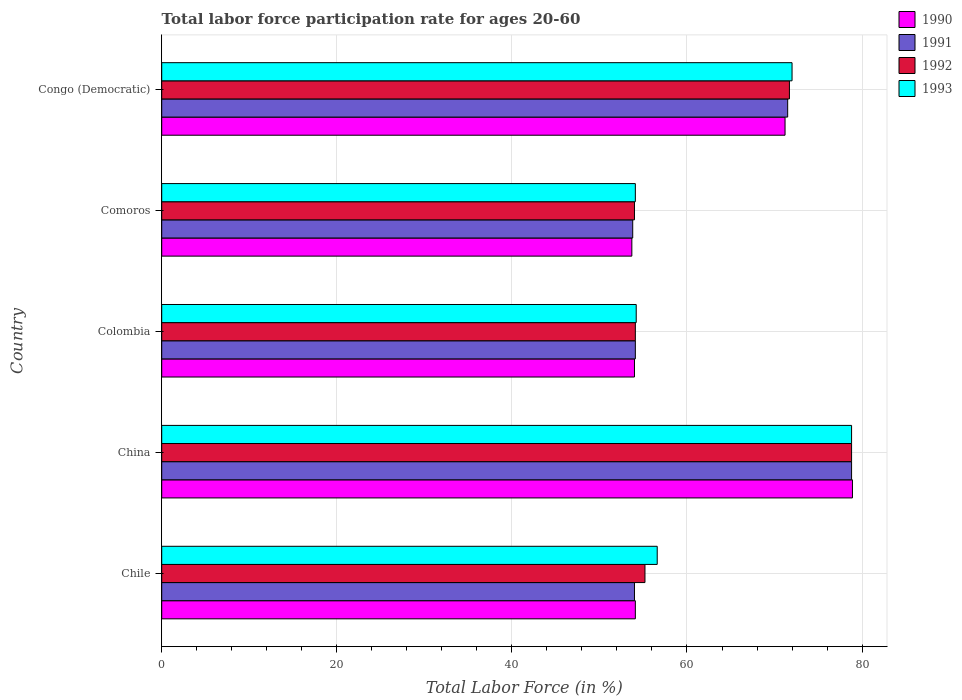How many different coloured bars are there?
Provide a succinct answer. 4. Are the number of bars per tick equal to the number of legend labels?
Offer a terse response. Yes. How many bars are there on the 1st tick from the top?
Make the answer very short. 4. How many bars are there on the 2nd tick from the bottom?
Provide a succinct answer. 4. In how many cases, is the number of bars for a given country not equal to the number of legend labels?
Provide a succinct answer. 0. What is the labor force participation rate in 1993 in Comoros?
Offer a terse response. 54.1. Across all countries, what is the maximum labor force participation rate in 1991?
Offer a very short reply. 78.8. Across all countries, what is the minimum labor force participation rate in 1993?
Your answer should be compact. 54.1. In which country was the labor force participation rate in 1991 minimum?
Your response must be concise. Comoros. What is the total labor force participation rate in 1993 in the graph?
Provide a succinct answer. 315.7. What is the difference between the labor force participation rate in 1990 in Chile and that in Comoros?
Your answer should be compact. 0.4. What is the average labor force participation rate in 1991 per country?
Your response must be concise. 62.44. What is the difference between the labor force participation rate in 1990 and labor force participation rate in 1991 in Comoros?
Your response must be concise. -0.1. What is the ratio of the labor force participation rate in 1991 in China to that in Comoros?
Keep it short and to the point. 1.46. What is the difference between the highest and the second highest labor force participation rate in 1991?
Provide a short and direct response. 7.3. What is the difference between the highest and the lowest labor force participation rate in 1991?
Offer a very short reply. 25. Is it the case that in every country, the sum of the labor force participation rate in 1993 and labor force participation rate in 1991 is greater than the sum of labor force participation rate in 1990 and labor force participation rate in 1992?
Offer a terse response. No. What does the 1st bar from the top in Comoros represents?
Your answer should be very brief. 1993. Are all the bars in the graph horizontal?
Make the answer very short. Yes. How many countries are there in the graph?
Your answer should be compact. 5. What is the difference between two consecutive major ticks on the X-axis?
Provide a short and direct response. 20. Does the graph contain any zero values?
Your answer should be compact. No. Does the graph contain grids?
Your answer should be very brief. Yes. Where does the legend appear in the graph?
Your response must be concise. Top right. How many legend labels are there?
Your response must be concise. 4. How are the legend labels stacked?
Keep it short and to the point. Vertical. What is the title of the graph?
Provide a succinct answer. Total labor force participation rate for ages 20-60. Does "1968" appear as one of the legend labels in the graph?
Provide a succinct answer. No. What is the label or title of the X-axis?
Provide a short and direct response. Total Labor Force (in %). What is the label or title of the Y-axis?
Offer a very short reply. Country. What is the Total Labor Force (in %) of 1990 in Chile?
Your answer should be very brief. 54.1. What is the Total Labor Force (in %) in 1991 in Chile?
Offer a terse response. 54. What is the Total Labor Force (in %) of 1992 in Chile?
Make the answer very short. 55.2. What is the Total Labor Force (in %) of 1993 in Chile?
Give a very brief answer. 56.6. What is the Total Labor Force (in %) in 1990 in China?
Give a very brief answer. 78.9. What is the Total Labor Force (in %) of 1991 in China?
Your answer should be very brief. 78.8. What is the Total Labor Force (in %) of 1992 in China?
Keep it short and to the point. 78.8. What is the Total Labor Force (in %) in 1993 in China?
Offer a very short reply. 78.8. What is the Total Labor Force (in %) of 1991 in Colombia?
Ensure brevity in your answer.  54.1. What is the Total Labor Force (in %) in 1992 in Colombia?
Provide a succinct answer. 54.1. What is the Total Labor Force (in %) in 1993 in Colombia?
Your answer should be very brief. 54.2. What is the Total Labor Force (in %) of 1990 in Comoros?
Your answer should be very brief. 53.7. What is the Total Labor Force (in %) of 1991 in Comoros?
Make the answer very short. 53.8. What is the Total Labor Force (in %) in 1993 in Comoros?
Ensure brevity in your answer.  54.1. What is the Total Labor Force (in %) in 1990 in Congo (Democratic)?
Provide a succinct answer. 71.2. What is the Total Labor Force (in %) of 1991 in Congo (Democratic)?
Ensure brevity in your answer.  71.5. What is the Total Labor Force (in %) of 1992 in Congo (Democratic)?
Offer a very short reply. 71.7. What is the Total Labor Force (in %) of 1993 in Congo (Democratic)?
Your response must be concise. 72. Across all countries, what is the maximum Total Labor Force (in %) of 1990?
Offer a very short reply. 78.9. Across all countries, what is the maximum Total Labor Force (in %) of 1991?
Your answer should be very brief. 78.8. Across all countries, what is the maximum Total Labor Force (in %) of 1992?
Ensure brevity in your answer.  78.8. Across all countries, what is the maximum Total Labor Force (in %) of 1993?
Ensure brevity in your answer.  78.8. Across all countries, what is the minimum Total Labor Force (in %) of 1990?
Ensure brevity in your answer.  53.7. Across all countries, what is the minimum Total Labor Force (in %) in 1991?
Offer a very short reply. 53.8. Across all countries, what is the minimum Total Labor Force (in %) in 1992?
Your answer should be very brief. 54. Across all countries, what is the minimum Total Labor Force (in %) of 1993?
Your response must be concise. 54.1. What is the total Total Labor Force (in %) of 1990 in the graph?
Provide a short and direct response. 311.9. What is the total Total Labor Force (in %) of 1991 in the graph?
Your response must be concise. 312.2. What is the total Total Labor Force (in %) of 1992 in the graph?
Give a very brief answer. 313.8. What is the total Total Labor Force (in %) of 1993 in the graph?
Keep it short and to the point. 315.7. What is the difference between the Total Labor Force (in %) in 1990 in Chile and that in China?
Your answer should be very brief. -24.8. What is the difference between the Total Labor Force (in %) in 1991 in Chile and that in China?
Make the answer very short. -24.8. What is the difference between the Total Labor Force (in %) in 1992 in Chile and that in China?
Keep it short and to the point. -23.6. What is the difference between the Total Labor Force (in %) in 1993 in Chile and that in China?
Offer a terse response. -22.2. What is the difference between the Total Labor Force (in %) in 1992 in Chile and that in Colombia?
Offer a terse response. 1.1. What is the difference between the Total Labor Force (in %) of 1993 in Chile and that in Colombia?
Keep it short and to the point. 2.4. What is the difference between the Total Labor Force (in %) of 1991 in Chile and that in Comoros?
Give a very brief answer. 0.2. What is the difference between the Total Labor Force (in %) of 1992 in Chile and that in Comoros?
Ensure brevity in your answer.  1.2. What is the difference between the Total Labor Force (in %) of 1993 in Chile and that in Comoros?
Your answer should be very brief. 2.5. What is the difference between the Total Labor Force (in %) of 1990 in Chile and that in Congo (Democratic)?
Your response must be concise. -17.1. What is the difference between the Total Labor Force (in %) of 1991 in Chile and that in Congo (Democratic)?
Make the answer very short. -17.5. What is the difference between the Total Labor Force (in %) of 1992 in Chile and that in Congo (Democratic)?
Give a very brief answer. -16.5. What is the difference between the Total Labor Force (in %) in 1993 in Chile and that in Congo (Democratic)?
Offer a terse response. -15.4. What is the difference between the Total Labor Force (in %) in 1990 in China and that in Colombia?
Your answer should be very brief. 24.9. What is the difference between the Total Labor Force (in %) in 1991 in China and that in Colombia?
Your response must be concise. 24.7. What is the difference between the Total Labor Force (in %) in 1992 in China and that in Colombia?
Your answer should be compact. 24.7. What is the difference between the Total Labor Force (in %) of 1993 in China and that in Colombia?
Keep it short and to the point. 24.6. What is the difference between the Total Labor Force (in %) of 1990 in China and that in Comoros?
Your answer should be very brief. 25.2. What is the difference between the Total Labor Force (in %) of 1992 in China and that in Comoros?
Your answer should be very brief. 24.8. What is the difference between the Total Labor Force (in %) in 1993 in China and that in Comoros?
Your response must be concise. 24.7. What is the difference between the Total Labor Force (in %) in 1991 in China and that in Congo (Democratic)?
Your response must be concise. 7.3. What is the difference between the Total Labor Force (in %) of 1992 in China and that in Congo (Democratic)?
Offer a very short reply. 7.1. What is the difference between the Total Labor Force (in %) in 1993 in China and that in Congo (Democratic)?
Provide a succinct answer. 6.8. What is the difference between the Total Labor Force (in %) in 1990 in Colombia and that in Comoros?
Keep it short and to the point. 0.3. What is the difference between the Total Labor Force (in %) of 1991 in Colombia and that in Comoros?
Your answer should be very brief. 0.3. What is the difference between the Total Labor Force (in %) of 1993 in Colombia and that in Comoros?
Provide a succinct answer. 0.1. What is the difference between the Total Labor Force (in %) of 1990 in Colombia and that in Congo (Democratic)?
Your response must be concise. -17.2. What is the difference between the Total Labor Force (in %) of 1991 in Colombia and that in Congo (Democratic)?
Offer a terse response. -17.4. What is the difference between the Total Labor Force (in %) of 1992 in Colombia and that in Congo (Democratic)?
Keep it short and to the point. -17.6. What is the difference between the Total Labor Force (in %) of 1993 in Colombia and that in Congo (Democratic)?
Your answer should be compact. -17.8. What is the difference between the Total Labor Force (in %) in 1990 in Comoros and that in Congo (Democratic)?
Provide a succinct answer. -17.5. What is the difference between the Total Labor Force (in %) in 1991 in Comoros and that in Congo (Democratic)?
Offer a terse response. -17.7. What is the difference between the Total Labor Force (in %) of 1992 in Comoros and that in Congo (Democratic)?
Keep it short and to the point. -17.7. What is the difference between the Total Labor Force (in %) in 1993 in Comoros and that in Congo (Democratic)?
Offer a terse response. -17.9. What is the difference between the Total Labor Force (in %) of 1990 in Chile and the Total Labor Force (in %) of 1991 in China?
Offer a very short reply. -24.7. What is the difference between the Total Labor Force (in %) in 1990 in Chile and the Total Labor Force (in %) in 1992 in China?
Offer a very short reply. -24.7. What is the difference between the Total Labor Force (in %) in 1990 in Chile and the Total Labor Force (in %) in 1993 in China?
Your response must be concise. -24.7. What is the difference between the Total Labor Force (in %) in 1991 in Chile and the Total Labor Force (in %) in 1992 in China?
Your answer should be very brief. -24.8. What is the difference between the Total Labor Force (in %) of 1991 in Chile and the Total Labor Force (in %) of 1993 in China?
Make the answer very short. -24.8. What is the difference between the Total Labor Force (in %) in 1992 in Chile and the Total Labor Force (in %) in 1993 in China?
Offer a very short reply. -23.6. What is the difference between the Total Labor Force (in %) of 1990 in Chile and the Total Labor Force (in %) of 1991 in Colombia?
Your answer should be compact. 0. What is the difference between the Total Labor Force (in %) of 1990 in Chile and the Total Labor Force (in %) of 1992 in Comoros?
Provide a short and direct response. 0.1. What is the difference between the Total Labor Force (in %) in 1990 in Chile and the Total Labor Force (in %) in 1993 in Comoros?
Your answer should be very brief. 0. What is the difference between the Total Labor Force (in %) in 1991 in Chile and the Total Labor Force (in %) in 1992 in Comoros?
Keep it short and to the point. 0. What is the difference between the Total Labor Force (in %) of 1992 in Chile and the Total Labor Force (in %) of 1993 in Comoros?
Offer a terse response. 1.1. What is the difference between the Total Labor Force (in %) in 1990 in Chile and the Total Labor Force (in %) in 1991 in Congo (Democratic)?
Ensure brevity in your answer.  -17.4. What is the difference between the Total Labor Force (in %) of 1990 in Chile and the Total Labor Force (in %) of 1992 in Congo (Democratic)?
Offer a terse response. -17.6. What is the difference between the Total Labor Force (in %) in 1990 in Chile and the Total Labor Force (in %) in 1993 in Congo (Democratic)?
Give a very brief answer. -17.9. What is the difference between the Total Labor Force (in %) in 1991 in Chile and the Total Labor Force (in %) in 1992 in Congo (Democratic)?
Provide a short and direct response. -17.7. What is the difference between the Total Labor Force (in %) in 1991 in Chile and the Total Labor Force (in %) in 1993 in Congo (Democratic)?
Your answer should be compact. -18. What is the difference between the Total Labor Force (in %) in 1992 in Chile and the Total Labor Force (in %) in 1993 in Congo (Democratic)?
Give a very brief answer. -16.8. What is the difference between the Total Labor Force (in %) of 1990 in China and the Total Labor Force (in %) of 1991 in Colombia?
Give a very brief answer. 24.8. What is the difference between the Total Labor Force (in %) in 1990 in China and the Total Labor Force (in %) in 1992 in Colombia?
Keep it short and to the point. 24.8. What is the difference between the Total Labor Force (in %) in 1990 in China and the Total Labor Force (in %) in 1993 in Colombia?
Your answer should be compact. 24.7. What is the difference between the Total Labor Force (in %) in 1991 in China and the Total Labor Force (in %) in 1992 in Colombia?
Provide a short and direct response. 24.7. What is the difference between the Total Labor Force (in %) in 1991 in China and the Total Labor Force (in %) in 1993 in Colombia?
Your answer should be compact. 24.6. What is the difference between the Total Labor Force (in %) in 1992 in China and the Total Labor Force (in %) in 1993 in Colombia?
Give a very brief answer. 24.6. What is the difference between the Total Labor Force (in %) in 1990 in China and the Total Labor Force (in %) in 1991 in Comoros?
Provide a succinct answer. 25.1. What is the difference between the Total Labor Force (in %) of 1990 in China and the Total Labor Force (in %) of 1992 in Comoros?
Keep it short and to the point. 24.9. What is the difference between the Total Labor Force (in %) in 1990 in China and the Total Labor Force (in %) in 1993 in Comoros?
Keep it short and to the point. 24.8. What is the difference between the Total Labor Force (in %) of 1991 in China and the Total Labor Force (in %) of 1992 in Comoros?
Make the answer very short. 24.8. What is the difference between the Total Labor Force (in %) in 1991 in China and the Total Labor Force (in %) in 1993 in Comoros?
Your answer should be compact. 24.7. What is the difference between the Total Labor Force (in %) of 1992 in China and the Total Labor Force (in %) of 1993 in Comoros?
Give a very brief answer. 24.7. What is the difference between the Total Labor Force (in %) in 1990 in China and the Total Labor Force (in %) in 1991 in Congo (Democratic)?
Give a very brief answer. 7.4. What is the difference between the Total Labor Force (in %) of 1991 in China and the Total Labor Force (in %) of 1992 in Congo (Democratic)?
Keep it short and to the point. 7.1. What is the difference between the Total Labor Force (in %) in 1990 in Colombia and the Total Labor Force (in %) in 1991 in Comoros?
Give a very brief answer. 0.2. What is the difference between the Total Labor Force (in %) in 1990 in Colombia and the Total Labor Force (in %) in 1992 in Comoros?
Make the answer very short. 0. What is the difference between the Total Labor Force (in %) of 1990 in Colombia and the Total Labor Force (in %) of 1993 in Comoros?
Provide a succinct answer. -0.1. What is the difference between the Total Labor Force (in %) in 1992 in Colombia and the Total Labor Force (in %) in 1993 in Comoros?
Provide a short and direct response. 0. What is the difference between the Total Labor Force (in %) in 1990 in Colombia and the Total Labor Force (in %) in 1991 in Congo (Democratic)?
Offer a terse response. -17.5. What is the difference between the Total Labor Force (in %) in 1990 in Colombia and the Total Labor Force (in %) in 1992 in Congo (Democratic)?
Give a very brief answer. -17.7. What is the difference between the Total Labor Force (in %) in 1990 in Colombia and the Total Labor Force (in %) in 1993 in Congo (Democratic)?
Provide a short and direct response. -18. What is the difference between the Total Labor Force (in %) of 1991 in Colombia and the Total Labor Force (in %) of 1992 in Congo (Democratic)?
Make the answer very short. -17.6. What is the difference between the Total Labor Force (in %) in 1991 in Colombia and the Total Labor Force (in %) in 1993 in Congo (Democratic)?
Keep it short and to the point. -17.9. What is the difference between the Total Labor Force (in %) in 1992 in Colombia and the Total Labor Force (in %) in 1993 in Congo (Democratic)?
Make the answer very short. -17.9. What is the difference between the Total Labor Force (in %) in 1990 in Comoros and the Total Labor Force (in %) in 1991 in Congo (Democratic)?
Provide a succinct answer. -17.8. What is the difference between the Total Labor Force (in %) of 1990 in Comoros and the Total Labor Force (in %) of 1993 in Congo (Democratic)?
Offer a terse response. -18.3. What is the difference between the Total Labor Force (in %) of 1991 in Comoros and the Total Labor Force (in %) of 1992 in Congo (Democratic)?
Offer a very short reply. -17.9. What is the difference between the Total Labor Force (in %) in 1991 in Comoros and the Total Labor Force (in %) in 1993 in Congo (Democratic)?
Your answer should be compact. -18.2. What is the average Total Labor Force (in %) in 1990 per country?
Provide a short and direct response. 62.38. What is the average Total Labor Force (in %) of 1991 per country?
Make the answer very short. 62.44. What is the average Total Labor Force (in %) in 1992 per country?
Offer a terse response. 62.76. What is the average Total Labor Force (in %) of 1993 per country?
Ensure brevity in your answer.  63.14. What is the difference between the Total Labor Force (in %) in 1990 and Total Labor Force (in %) in 1991 in Chile?
Your answer should be very brief. 0.1. What is the difference between the Total Labor Force (in %) of 1990 and Total Labor Force (in %) of 1991 in China?
Provide a short and direct response. 0.1. What is the difference between the Total Labor Force (in %) of 1990 and Total Labor Force (in %) of 1992 in China?
Your answer should be very brief. 0.1. What is the difference between the Total Labor Force (in %) of 1991 and Total Labor Force (in %) of 1993 in China?
Your answer should be very brief. 0. What is the difference between the Total Labor Force (in %) in 1990 and Total Labor Force (in %) in 1991 in Colombia?
Your response must be concise. -0.1. What is the difference between the Total Labor Force (in %) of 1990 and Total Labor Force (in %) of 1992 in Colombia?
Your answer should be very brief. -0.1. What is the difference between the Total Labor Force (in %) in 1991 and Total Labor Force (in %) in 1993 in Colombia?
Offer a terse response. -0.1. What is the difference between the Total Labor Force (in %) of 1990 and Total Labor Force (in %) of 1992 in Comoros?
Your answer should be compact. -0.3. What is the difference between the Total Labor Force (in %) in 1990 and Total Labor Force (in %) in 1993 in Comoros?
Your answer should be very brief. -0.4. What is the difference between the Total Labor Force (in %) in 1991 and Total Labor Force (in %) in 1992 in Comoros?
Keep it short and to the point. -0.2. What is the difference between the Total Labor Force (in %) in 1991 and Total Labor Force (in %) in 1993 in Comoros?
Your response must be concise. -0.3. What is the difference between the Total Labor Force (in %) of 1992 and Total Labor Force (in %) of 1993 in Comoros?
Provide a short and direct response. -0.1. What is the difference between the Total Labor Force (in %) of 1990 and Total Labor Force (in %) of 1992 in Congo (Democratic)?
Give a very brief answer. -0.5. What is the difference between the Total Labor Force (in %) in 1992 and Total Labor Force (in %) in 1993 in Congo (Democratic)?
Provide a short and direct response. -0.3. What is the ratio of the Total Labor Force (in %) in 1990 in Chile to that in China?
Offer a very short reply. 0.69. What is the ratio of the Total Labor Force (in %) in 1991 in Chile to that in China?
Make the answer very short. 0.69. What is the ratio of the Total Labor Force (in %) in 1992 in Chile to that in China?
Keep it short and to the point. 0.7. What is the ratio of the Total Labor Force (in %) in 1993 in Chile to that in China?
Ensure brevity in your answer.  0.72. What is the ratio of the Total Labor Force (in %) in 1991 in Chile to that in Colombia?
Provide a succinct answer. 1. What is the ratio of the Total Labor Force (in %) of 1992 in Chile to that in Colombia?
Make the answer very short. 1.02. What is the ratio of the Total Labor Force (in %) of 1993 in Chile to that in Colombia?
Offer a terse response. 1.04. What is the ratio of the Total Labor Force (in %) in 1990 in Chile to that in Comoros?
Your answer should be compact. 1.01. What is the ratio of the Total Labor Force (in %) in 1992 in Chile to that in Comoros?
Give a very brief answer. 1.02. What is the ratio of the Total Labor Force (in %) of 1993 in Chile to that in Comoros?
Offer a terse response. 1.05. What is the ratio of the Total Labor Force (in %) in 1990 in Chile to that in Congo (Democratic)?
Provide a succinct answer. 0.76. What is the ratio of the Total Labor Force (in %) in 1991 in Chile to that in Congo (Democratic)?
Make the answer very short. 0.76. What is the ratio of the Total Labor Force (in %) in 1992 in Chile to that in Congo (Democratic)?
Your answer should be compact. 0.77. What is the ratio of the Total Labor Force (in %) in 1993 in Chile to that in Congo (Democratic)?
Give a very brief answer. 0.79. What is the ratio of the Total Labor Force (in %) of 1990 in China to that in Colombia?
Offer a very short reply. 1.46. What is the ratio of the Total Labor Force (in %) of 1991 in China to that in Colombia?
Make the answer very short. 1.46. What is the ratio of the Total Labor Force (in %) in 1992 in China to that in Colombia?
Ensure brevity in your answer.  1.46. What is the ratio of the Total Labor Force (in %) of 1993 in China to that in Colombia?
Your response must be concise. 1.45. What is the ratio of the Total Labor Force (in %) of 1990 in China to that in Comoros?
Make the answer very short. 1.47. What is the ratio of the Total Labor Force (in %) of 1991 in China to that in Comoros?
Provide a succinct answer. 1.46. What is the ratio of the Total Labor Force (in %) of 1992 in China to that in Comoros?
Make the answer very short. 1.46. What is the ratio of the Total Labor Force (in %) of 1993 in China to that in Comoros?
Your answer should be very brief. 1.46. What is the ratio of the Total Labor Force (in %) of 1990 in China to that in Congo (Democratic)?
Keep it short and to the point. 1.11. What is the ratio of the Total Labor Force (in %) of 1991 in China to that in Congo (Democratic)?
Give a very brief answer. 1.1. What is the ratio of the Total Labor Force (in %) in 1992 in China to that in Congo (Democratic)?
Ensure brevity in your answer.  1.1. What is the ratio of the Total Labor Force (in %) in 1993 in China to that in Congo (Democratic)?
Your answer should be compact. 1.09. What is the ratio of the Total Labor Force (in %) of 1990 in Colombia to that in Comoros?
Ensure brevity in your answer.  1.01. What is the ratio of the Total Labor Force (in %) of 1991 in Colombia to that in Comoros?
Offer a terse response. 1.01. What is the ratio of the Total Labor Force (in %) of 1993 in Colombia to that in Comoros?
Keep it short and to the point. 1. What is the ratio of the Total Labor Force (in %) in 1990 in Colombia to that in Congo (Democratic)?
Provide a succinct answer. 0.76. What is the ratio of the Total Labor Force (in %) of 1991 in Colombia to that in Congo (Democratic)?
Offer a very short reply. 0.76. What is the ratio of the Total Labor Force (in %) of 1992 in Colombia to that in Congo (Democratic)?
Provide a succinct answer. 0.75. What is the ratio of the Total Labor Force (in %) in 1993 in Colombia to that in Congo (Democratic)?
Keep it short and to the point. 0.75. What is the ratio of the Total Labor Force (in %) in 1990 in Comoros to that in Congo (Democratic)?
Your answer should be very brief. 0.75. What is the ratio of the Total Labor Force (in %) in 1991 in Comoros to that in Congo (Democratic)?
Provide a succinct answer. 0.75. What is the ratio of the Total Labor Force (in %) of 1992 in Comoros to that in Congo (Democratic)?
Provide a short and direct response. 0.75. What is the ratio of the Total Labor Force (in %) of 1993 in Comoros to that in Congo (Democratic)?
Your response must be concise. 0.75. What is the difference between the highest and the second highest Total Labor Force (in %) in 1990?
Provide a short and direct response. 7.7. What is the difference between the highest and the second highest Total Labor Force (in %) of 1991?
Give a very brief answer. 7.3. What is the difference between the highest and the lowest Total Labor Force (in %) in 1990?
Make the answer very short. 25.2. What is the difference between the highest and the lowest Total Labor Force (in %) of 1991?
Offer a very short reply. 25. What is the difference between the highest and the lowest Total Labor Force (in %) in 1992?
Provide a succinct answer. 24.8. What is the difference between the highest and the lowest Total Labor Force (in %) in 1993?
Provide a succinct answer. 24.7. 